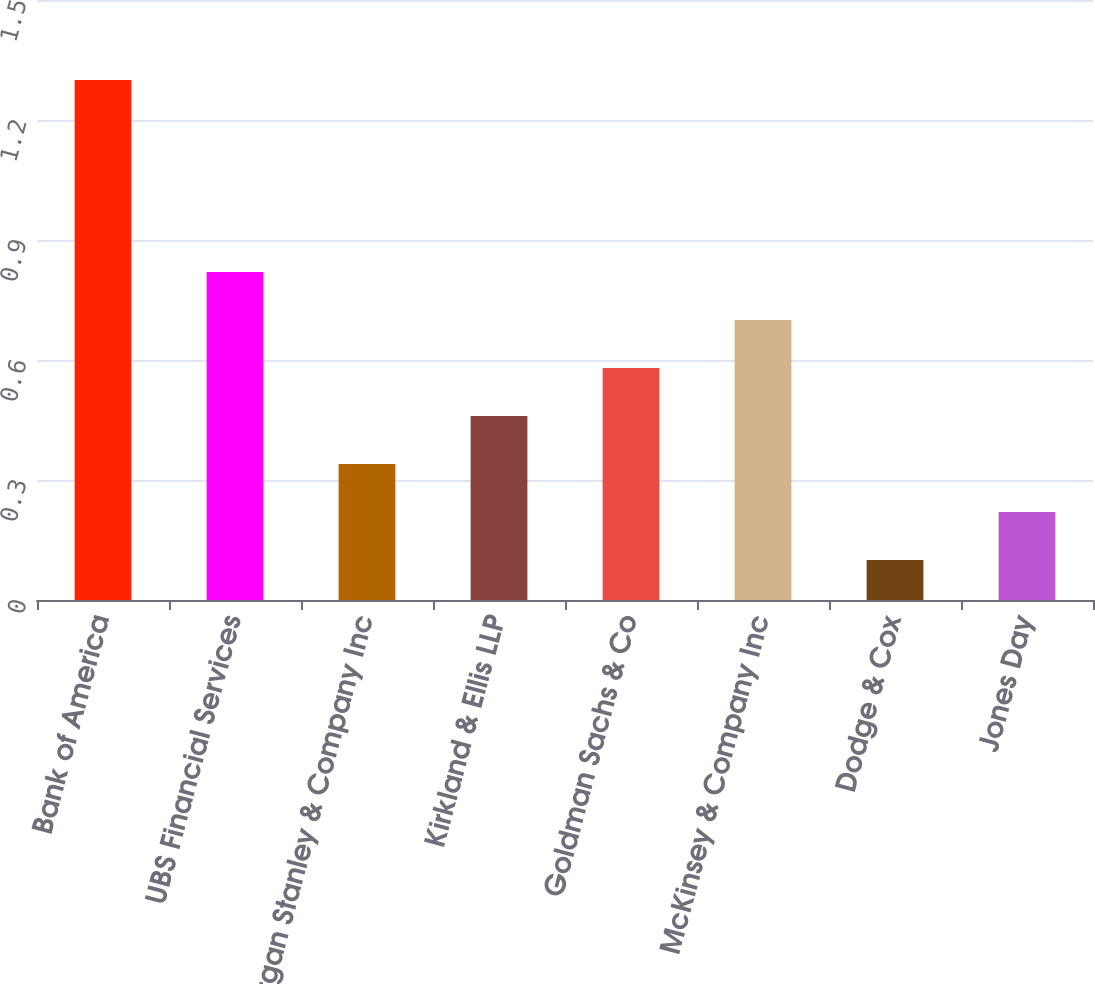Convert chart to OTSL. <chart><loc_0><loc_0><loc_500><loc_500><bar_chart><fcel>Bank of America<fcel>UBS Financial Services<fcel>Morgan Stanley & Company Inc<fcel>Kirkland & Ellis LLP<fcel>Goldman Sachs & Co<fcel>McKinsey & Company Inc<fcel>Dodge & Cox<fcel>Jones Day<nl><fcel>1.3<fcel>0.82<fcel>0.34<fcel>0.46<fcel>0.58<fcel>0.7<fcel>0.1<fcel>0.22<nl></chart> 